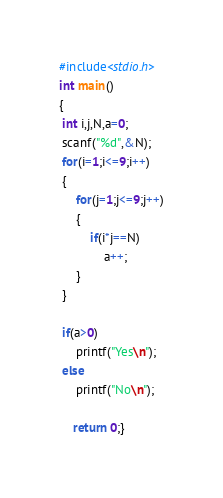<code> <loc_0><loc_0><loc_500><loc_500><_C_>#include<stdio.h>
int main()
{
 int i,j,N,a=0;
 scanf("%d",&N);
 for(i=1;i<=9;i++)
 {
	 for(j=1;j<=9;j++)
	 {
		 if(i*j==N)
			 a++;
	 }
 }
  
 if(a>0)
	 printf("Yes\n");
 else
	 printf("No\n");

	return 0;}
</code> 